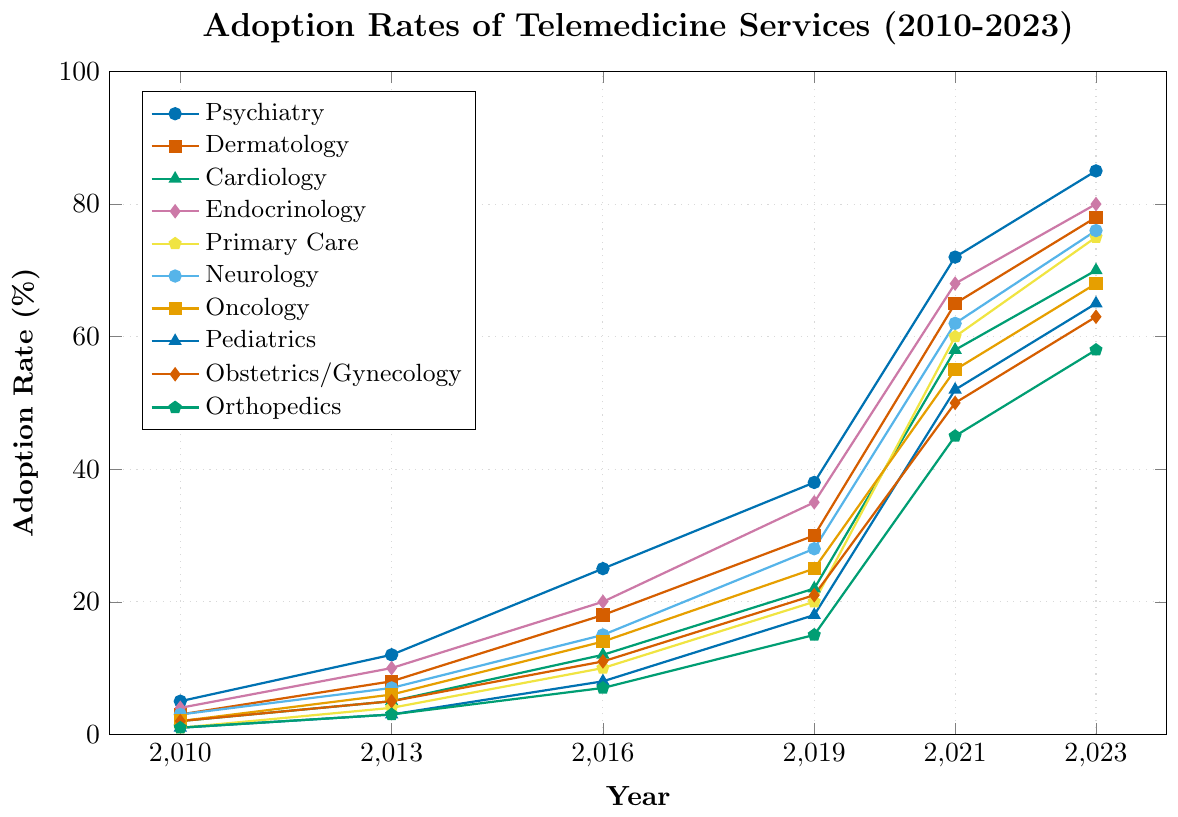Which specialty had the highest telemedicine adoption rate in 2023? Observe the values at the 2023 point for all lines representing different specialties, the highest adoption rate is for Psychiatry with 85%.
Answer: Psychiatry How did the adoption rate for Endocrinology change from 2010 to 2023? Look at the adoption rate for Endocrinology in 2010 and compare it with the rate in 2023. The rate increased from 4% to 80%, showing a growth of 76%.
Answer: Increased by 76% Which two specialties had the same adoption rate in 2019 and what was it? Identify the lines for each specialty at the 2019 mark, seeing that both Obstetrics/Gynecology and Orthopedics have the same adoption rate of 15%.
Answer: Obstetrics/Gynecology and Orthopedics, 15% Comparing 2010 and 2021, which specialty had the least change in adoption rate? Calculate the change in adoption rate for each specialty between 2010 and 2021. Dermatology changed by 62%, which is the least change among all specialties.
Answer: Dermatology What is the average adoption rate in 2023 across all specialties? Sum the adoption rates for all specialties in 2023 and divide by the number of specialties. (85 + 78 + 70 + 80 + 75 + 76 + 68 + 65 + 63 + 58)/10 = 718/10 = 71.8
Answer: 71.8% Which specialty showed the highest increase in adoption rate between 2019 and 2021? Calculate the difference in adoption rate for each specialty between 2019 and 2021. Psychiatry increased by 34%, the highest increase.
Answer: Psychiatry Between 2016 and 2023, which specialty showed the second highest increase in adoption rate? Calculate the increase for each specialty from 2016 to 2023, and find the second highest value. Endocrinology shows an increase of 60%, which is the second highest after Psychiatry’s 60%.
Answer: Endocrinology During which year did Oncology first surpass a 50% adoption rate? Identify the year on Oncology's line that first reaches or exceeds 50%, which happens in 2021.
Answer: 2021 In 2023, which specialties have an adoption rate between 60% and 70%? Identify the lines representing specialties that fall between 60% and 70% for the 2023 point. Oncology, Pediatrics, and Obstetrics/Gynecology fit in this range.
Answer: Oncology, Pediatrics, and Obstetrics/Gynecology How much did the adoption rate for Primary Care increase from 2013 to 2023? Subtract the 2013 adoption rate for Primary Care from the 2023 rate: 75% - 4% = 71%.
Answer: Increased by 71% 